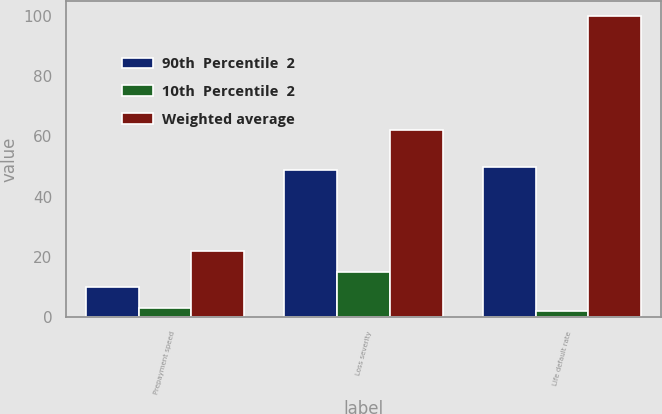Convert chart to OTSL. <chart><loc_0><loc_0><loc_500><loc_500><stacked_bar_chart><ecel><fcel>Prepayment speed<fcel>Loss severity<fcel>Life default rate<nl><fcel>90th  Percentile  2<fcel>10<fcel>49<fcel>50<nl><fcel>10th  Percentile  2<fcel>3<fcel>15<fcel>2<nl><fcel>Weighted average<fcel>22<fcel>62<fcel>100<nl></chart> 